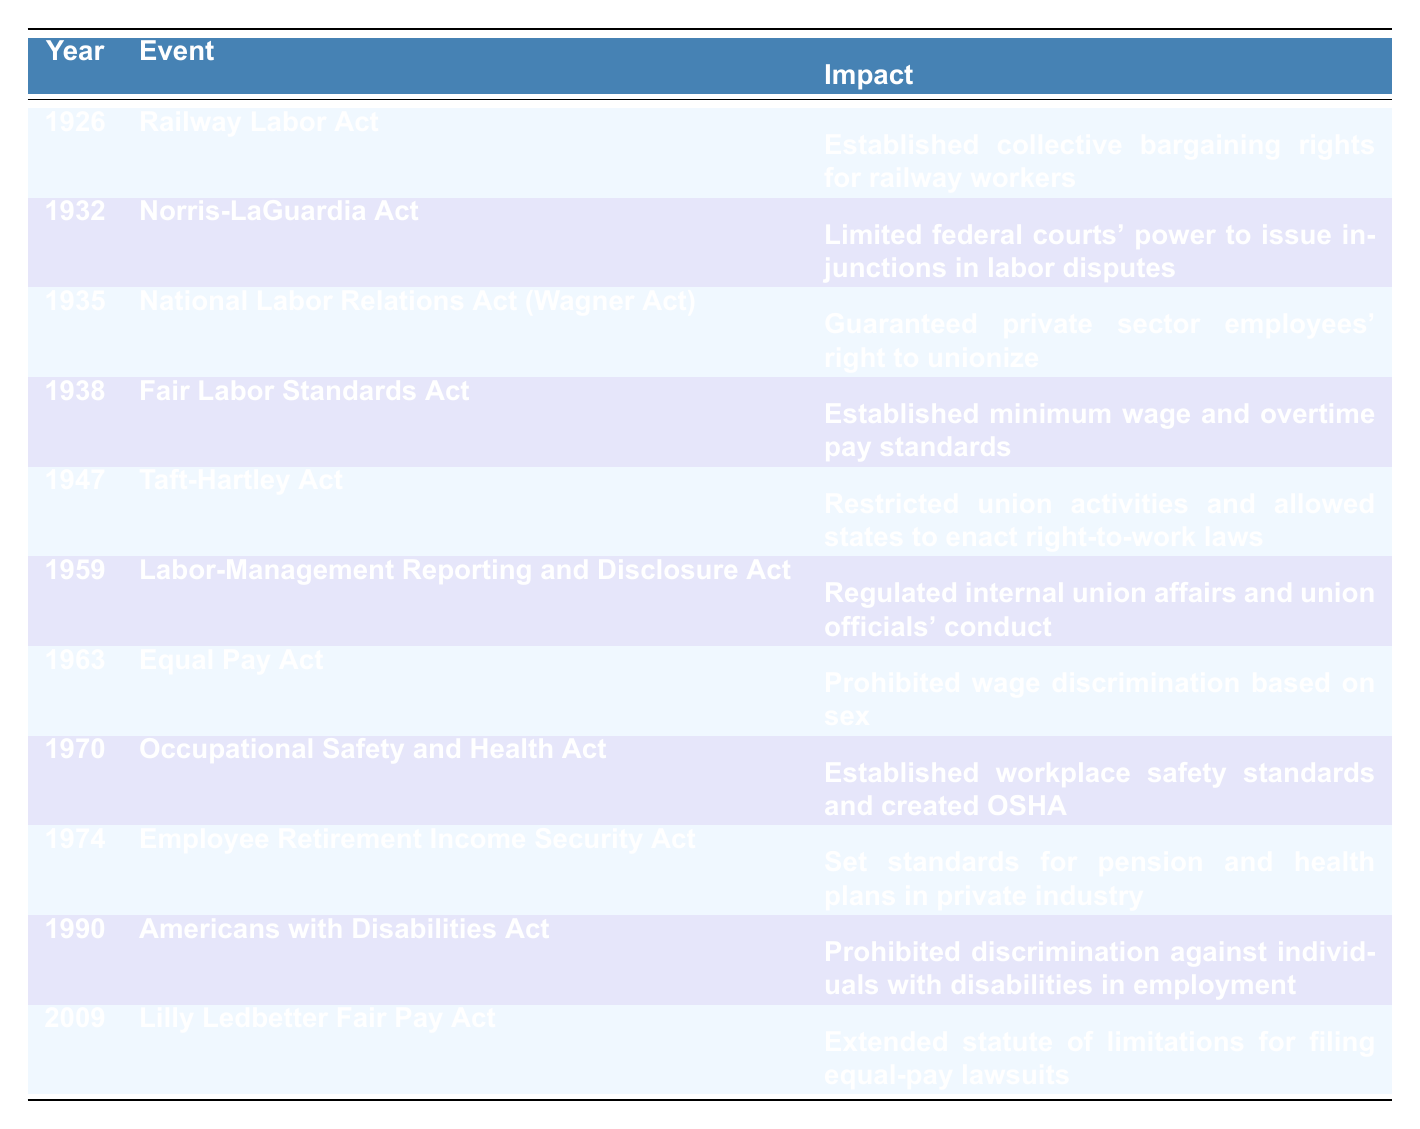What year was the Fair Labor Standards Act enacted? The table indicates the events that took place in each year, and the Fair Labor Standards Act is listed under the year 1938.
Answer: 1938 What impact did the Taft-Hartley Act have on union activities? Referring to the table, the Taft-Hartley Act is noted to have restricted union activities and allowed states to enact right-to-work laws.
Answer: It restricted union activities How many major labor law changes occurred between 1932 and 1959? The years from 1932 to 1959 include the following events: Norris-LaGuardia Act (1932), National Labor Relations Act (1935), Fair Labor Standards Act (1938), Taft-Hartley Act (1947), and Labor-Management Reporting and Disclosure Act (1959), totaling five events.
Answer: 5 Which act established minimum wage and overtime pay standards? The table shows that the Fair Labor Standards Act is the event that established minimum wage and overtime pay standards, enacted in 1938.
Answer: Fair Labor Standards Act Is it true that the Equal Pay Act prohibits wage discrimination based on race? According to the table, the Equal Pay Act prohibits wage discrimination based on sex, not race. Therefore, the statement is false.
Answer: False What is the earliest event listed in the table and what was its impact? The earliest event in the table is the Railway Labor Act in 1926, which established collective bargaining rights for railway workers.
Answer: Railway Labor Act; established collective bargaining rights for railway workers In which years did legislation specifically address workplace safety? The table shows that the Occupational Safety and Health Act, enacted in 1970, specifically addresses workplace safety. Therefore, the year to note is 1970.
Answer: 1970 What is the difference in years between the Norris-LaGuardia Act and the Lilly Ledbetter Fair Pay Act? The Norris-LaGuardia Act was enacted in 1932, and the Lilly Ledbetter Fair Pay Act was enacted in 2009. The difference is 2009 - 1932 = 77 years.
Answer: 77 years Which two acts directly pertain to labor rights, and what years were they enacted? The two acts that directly pertain to labor rights are the National Labor Relations Act (Wagner Act) from 1935 and the Taft-Hartley Act from 1947.
Answer: NLRA (1935) and Taft-Hartley Act (1947) Did any of the listed acts address issues of discrimination? Yes, both the Equal Pay Act (1963) and the Americans with Disabilities Act (1990) addressed issues of discrimination based on sex and disability, respectively.
Answer: Yes 